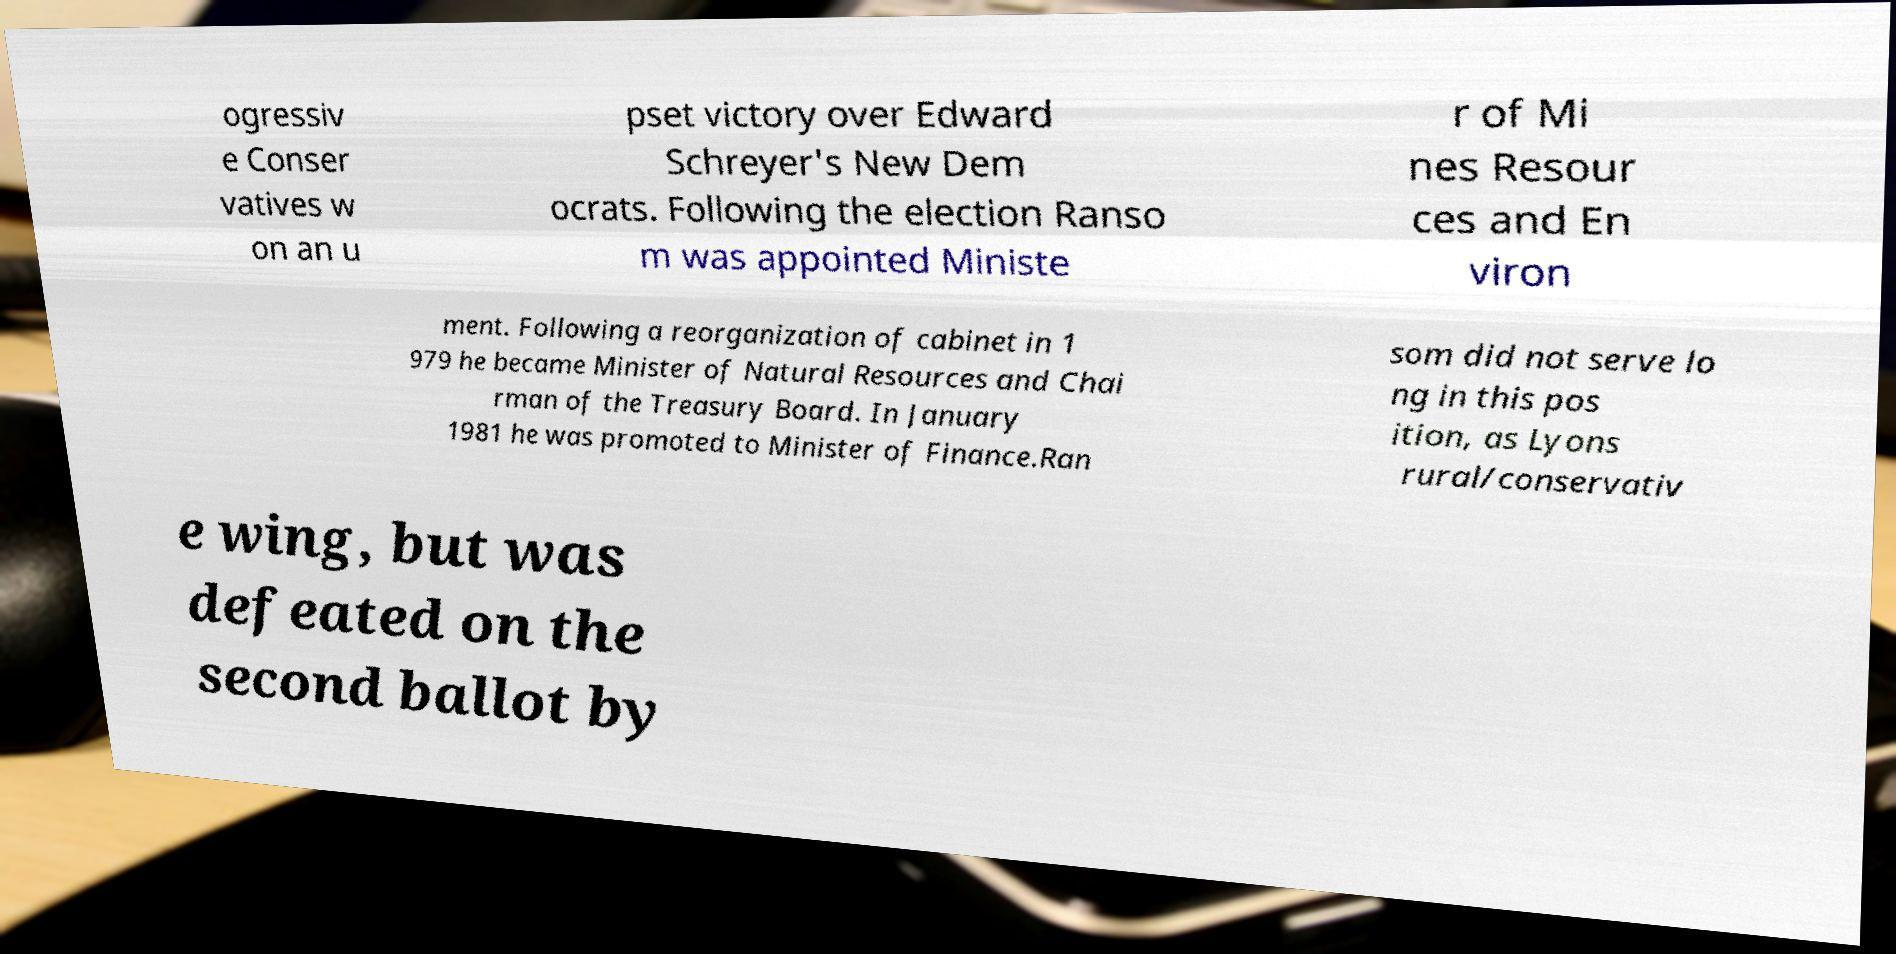Please identify and transcribe the text found in this image. ogressiv e Conser vatives w on an u pset victory over Edward Schreyer's New Dem ocrats. Following the election Ranso m was appointed Ministe r of Mi nes Resour ces and En viron ment. Following a reorganization of cabinet in 1 979 he became Minister of Natural Resources and Chai rman of the Treasury Board. In January 1981 he was promoted to Minister of Finance.Ran som did not serve lo ng in this pos ition, as Lyons rural/conservativ e wing, but was defeated on the second ballot by 